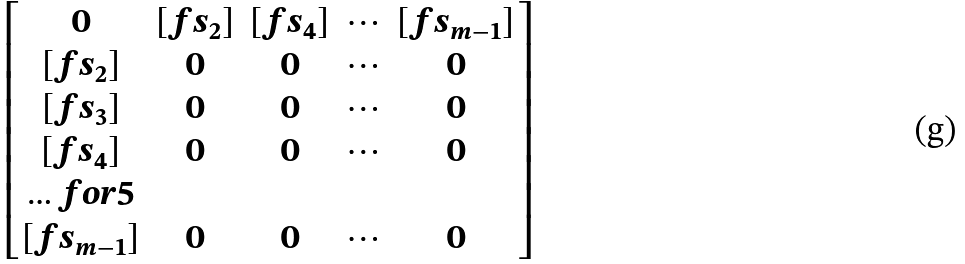<formula> <loc_0><loc_0><loc_500><loc_500>\begin{bmatrix} 0 & [ f s _ { 2 } ] & [ f s _ { 4 } ] & \cdots & [ f s _ { m - 1 } ] \\ [ f s _ { 2 } ] & 0 & 0 & \cdots & 0 \\ [ f s _ { 3 } ] & 0 & 0 & \cdots & 0 \\ [ f s _ { 4 } ] & 0 & 0 & \cdots & 0 \\ \hdots f o r { 5 } \\ [ f s _ { m - 1 } ] & 0 & 0 & \cdots & 0 \end{bmatrix}</formula> 